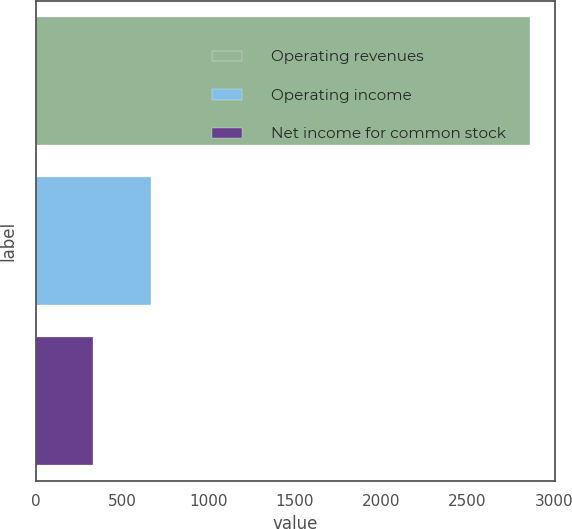Convert chart to OTSL. <chart><loc_0><loc_0><loc_500><loc_500><bar_chart><fcel>Operating revenues<fcel>Operating income<fcel>Net income for common stock<nl><fcel>2865<fcel>666<fcel>332<nl></chart> 